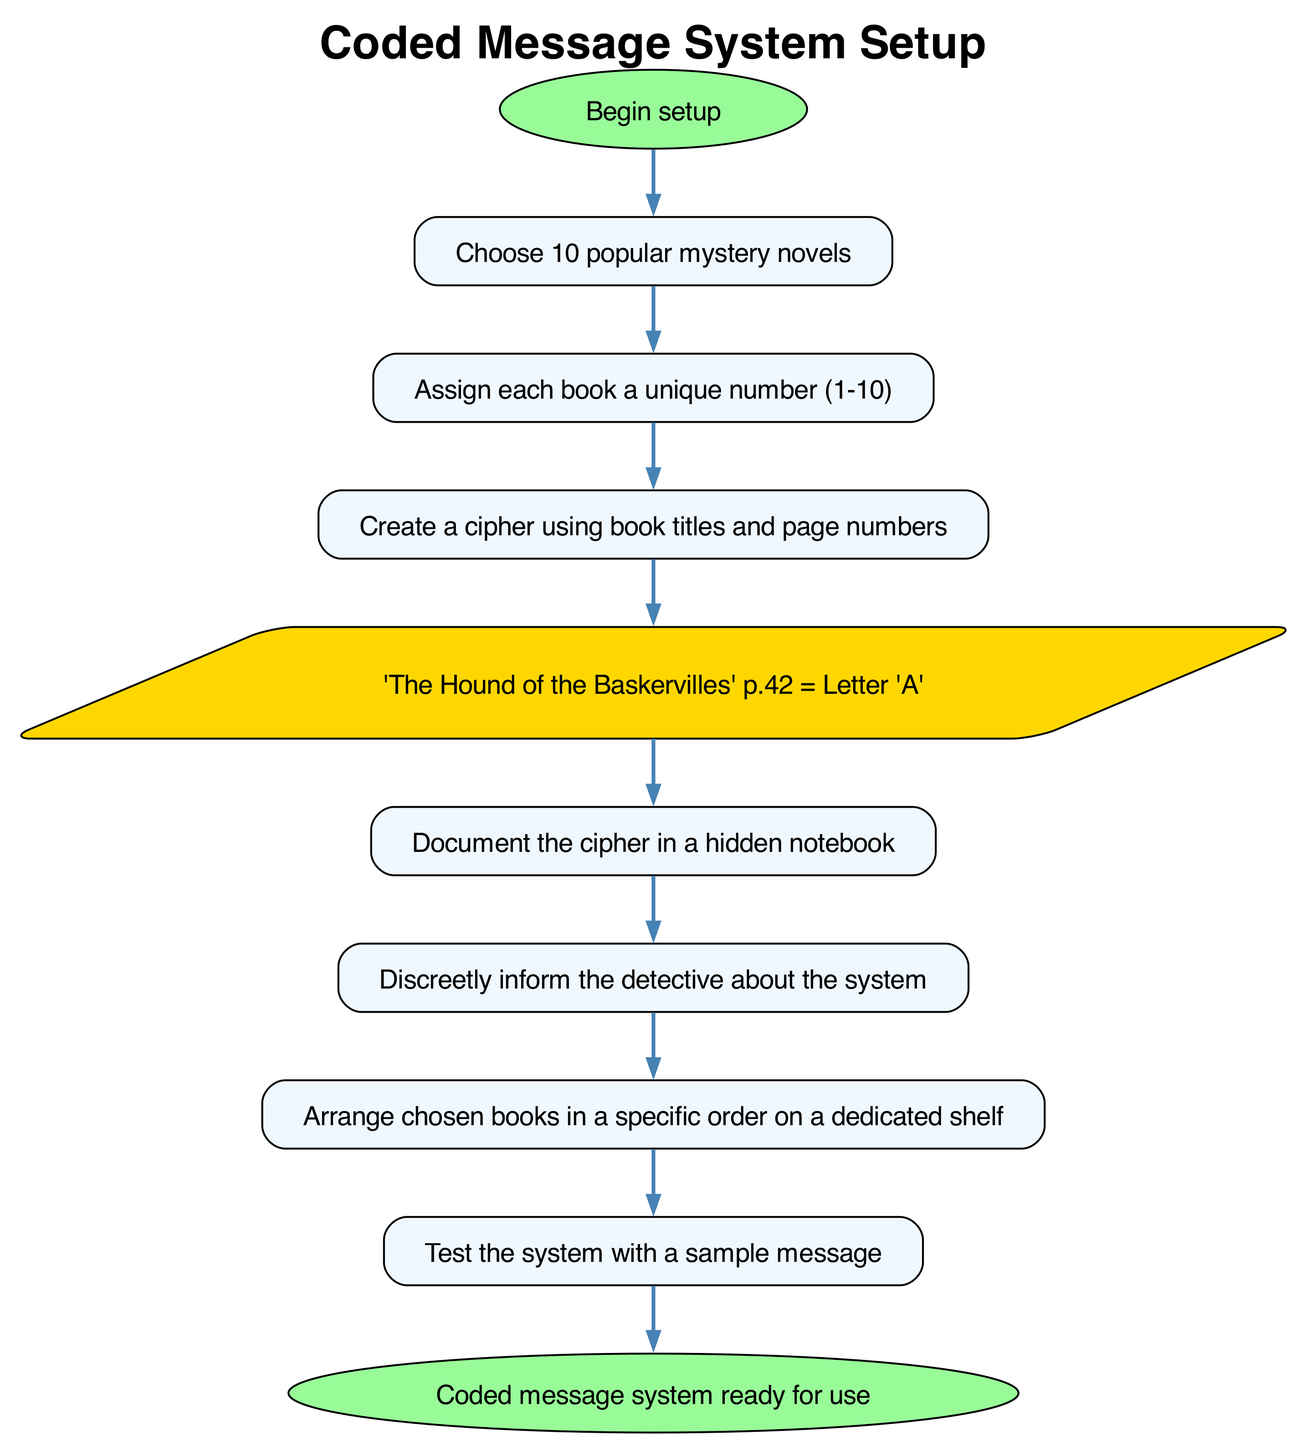What is the first step in setting up the coded message system? The first step is labeled "Begin setup," which indicates the initiation of the process.
Answer: Begin setup How many books need to be selected for the scheme? The diagram specifies that 10 popular mystery novels need to be chosen, indicating the required number.
Answer: 10 What shape is used for the "Create a cipher" step? In the diagram, the "Create a cipher" step is represented in a rectangular node, which is the standard shape for process steps.
Answer: Rectangle What follows after documenting the cipher? After the "Document the cipher" step, the next step is to "Discreetly inform the detective about the system," indicating the flow of information.
Answer: Discreetly inform the detective about the system Which step serves as an example in the flowchart? The flowchart includes a specific example labeled "'The Hound of the Baskervilles' p.42 = Letter 'A'," illustrating how the cipher operates.
Answer: 'The Hound of the Baskervilles' p.42 = Letter 'A' What total number of edges does the diagram contain? By counting all direct connections in the flowchart, the total number of flows (or edges) is nine, connecting the various steps sequentially.
Answer: 9 What type of node is used to illustrate “example”? The flowchart depicts the "example" step in a parallelogram shape, which is commonly used to represent examples or irregular steps within a process.
Answer: Parallelogram What is the last step in the setup process? The final step in the setup process is denoted as "Coded message system ready for use," indicating the completion of the entire procedure.
Answer: Coded message system ready for use After selecting books, what is the immediate next step? Following the "Choose 10 popular mystery novels" step, the immediate next step is to "Assign each book a unique number (1-10)," indicating the next action in the sequence.
Answer: Assign each book a unique number (1-10) 